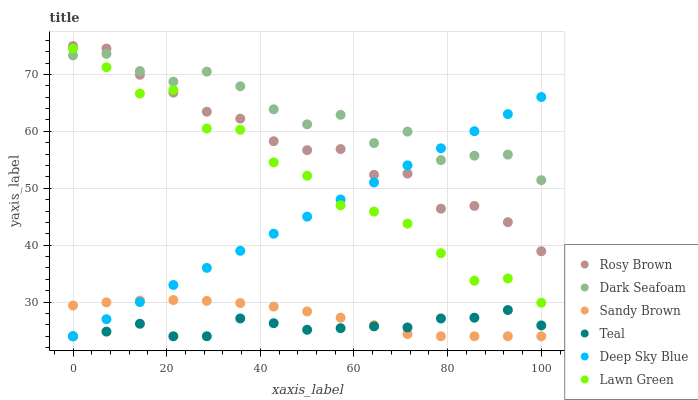Does Teal have the minimum area under the curve?
Answer yes or no. Yes. Does Dark Seafoam have the maximum area under the curve?
Answer yes or no. Yes. Does Rosy Brown have the minimum area under the curve?
Answer yes or no. No. Does Rosy Brown have the maximum area under the curve?
Answer yes or no. No. Is Deep Sky Blue the smoothest?
Answer yes or no. Yes. Is Dark Seafoam the roughest?
Answer yes or no. Yes. Is Teal the smoothest?
Answer yes or no. No. Is Teal the roughest?
Answer yes or no. No. Does Teal have the lowest value?
Answer yes or no. Yes. Does Rosy Brown have the lowest value?
Answer yes or no. No. Does Rosy Brown have the highest value?
Answer yes or no. Yes. Does Teal have the highest value?
Answer yes or no. No. Is Sandy Brown less than Lawn Green?
Answer yes or no. Yes. Is Lawn Green greater than Sandy Brown?
Answer yes or no. Yes. Does Deep Sky Blue intersect Dark Seafoam?
Answer yes or no. Yes. Is Deep Sky Blue less than Dark Seafoam?
Answer yes or no. No. Is Deep Sky Blue greater than Dark Seafoam?
Answer yes or no. No. Does Sandy Brown intersect Lawn Green?
Answer yes or no. No. 